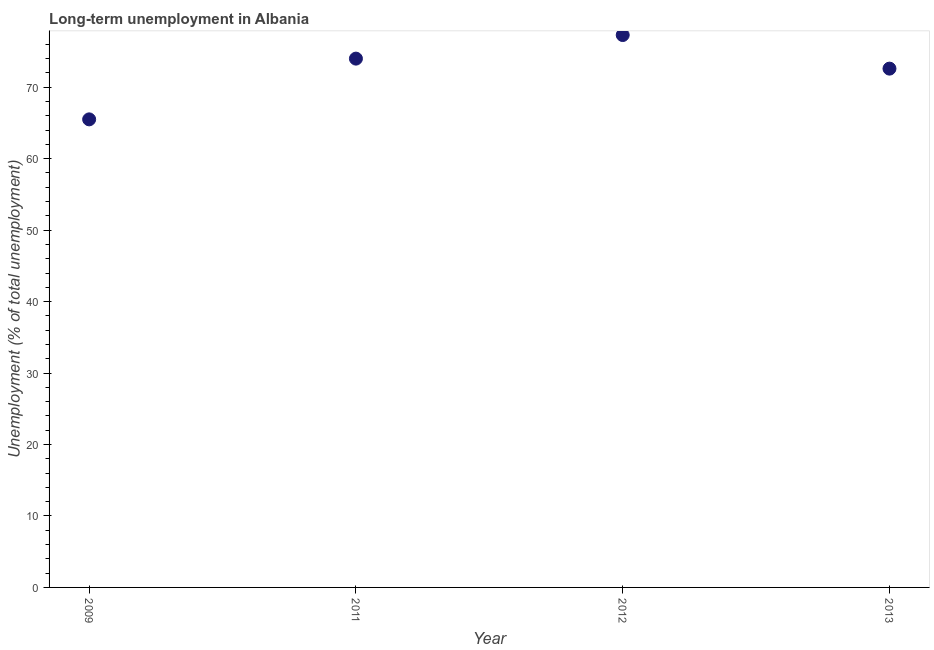What is the long-term unemployment in 2012?
Provide a short and direct response. 77.3. Across all years, what is the maximum long-term unemployment?
Offer a very short reply. 77.3. Across all years, what is the minimum long-term unemployment?
Provide a short and direct response. 65.5. What is the sum of the long-term unemployment?
Give a very brief answer. 289.4. What is the difference between the long-term unemployment in 2009 and 2013?
Provide a succinct answer. -7.1. What is the average long-term unemployment per year?
Give a very brief answer. 72.35. What is the median long-term unemployment?
Make the answer very short. 73.3. Do a majority of the years between 2013 and 2012 (inclusive) have long-term unemployment greater than 16 %?
Provide a succinct answer. No. What is the ratio of the long-term unemployment in 2009 to that in 2012?
Your answer should be very brief. 0.85. Is the long-term unemployment in 2012 less than that in 2013?
Keep it short and to the point. No. Is the difference between the long-term unemployment in 2011 and 2013 greater than the difference between any two years?
Provide a short and direct response. No. What is the difference between the highest and the second highest long-term unemployment?
Your response must be concise. 3.3. What is the difference between the highest and the lowest long-term unemployment?
Provide a short and direct response. 11.8. In how many years, is the long-term unemployment greater than the average long-term unemployment taken over all years?
Provide a short and direct response. 3. Does the long-term unemployment monotonically increase over the years?
Your answer should be very brief. No. How many dotlines are there?
Keep it short and to the point. 1. How many years are there in the graph?
Provide a short and direct response. 4. What is the difference between two consecutive major ticks on the Y-axis?
Your answer should be very brief. 10. Are the values on the major ticks of Y-axis written in scientific E-notation?
Your answer should be very brief. No. Does the graph contain grids?
Ensure brevity in your answer.  No. What is the title of the graph?
Keep it short and to the point. Long-term unemployment in Albania. What is the label or title of the X-axis?
Your answer should be compact. Year. What is the label or title of the Y-axis?
Provide a succinct answer. Unemployment (% of total unemployment). What is the Unemployment (% of total unemployment) in 2009?
Keep it short and to the point. 65.5. What is the Unemployment (% of total unemployment) in 2012?
Provide a succinct answer. 77.3. What is the Unemployment (% of total unemployment) in 2013?
Your answer should be very brief. 72.6. What is the difference between the Unemployment (% of total unemployment) in 2009 and 2013?
Your answer should be very brief. -7.1. What is the difference between the Unemployment (% of total unemployment) in 2011 and 2013?
Make the answer very short. 1.4. What is the difference between the Unemployment (% of total unemployment) in 2012 and 2013?
Make the answer very short. 4.7. What is the ratio of the Unemployment (% of total unemployment) in 2009 to that in 2011?
Offer a terse response. 0.89. What is the ratio of the Unemployment (% of total unemployment) in 2009 to that in 2012?
Your response must be concise. 0.85. What is the ratio of the Unemployment (% of total unemployment) in 2009 to that in 2013?
Give a very brief answer. 0.9. What is the ratio of the Unemployment (% of total unemployment) in 2012 to that in 2013?
Provide a succinct answer. 1.06. 